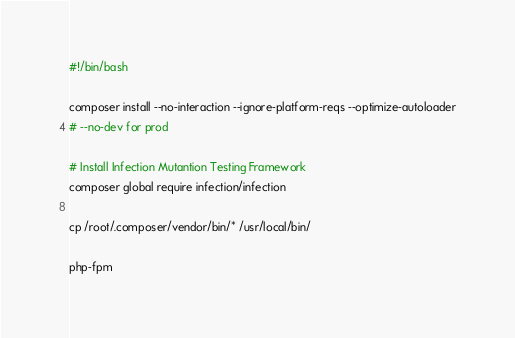Convert code to text. <code><loc_0><loc_0><loc_500><loc_500><_Bash_>#!/bin/bash

composer install --no-interaction --ignore-platform-reqs --optimize-autoloader
# --no-dev for prod

# Install Infection Mutantion Testing Framework
composer global require infection/infection

cp /root/.composer/vendor/bin/* /usr/local/bin/

php-fpm
</code> 